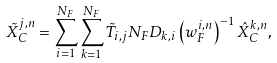<formula> <loc_0><loc_0><loc_500><loc_500>\tilde { X } _ { C } ^ { j , n } = \sum ^ { N _ { F } } _ { i = 1 } \sum ^ { N _ { F } } _ { k = 1 } \tilde { T } _ { i , j } N _ { F } D _ { k , i } \left ( w _ { F } ^ { i , n } \right ) ^ { - 1 } \hat { X } _ { C } ^ { k , n } ,</formula> 